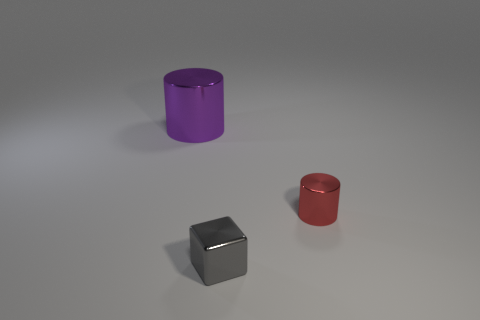Add 1 metallic blocks. How many objects exist? 4 Subtract all blocks. How many objects are left? 2 Subtract all big blue blocks. Subtract all large purple objects. How many objects are left? 2 Add 2 purple things. How many purple things are left? 3 Add 2 gray metallic things. How many gray metallic things exist? 3 Subtract 0 brown blocks. How many objects are left? 3 